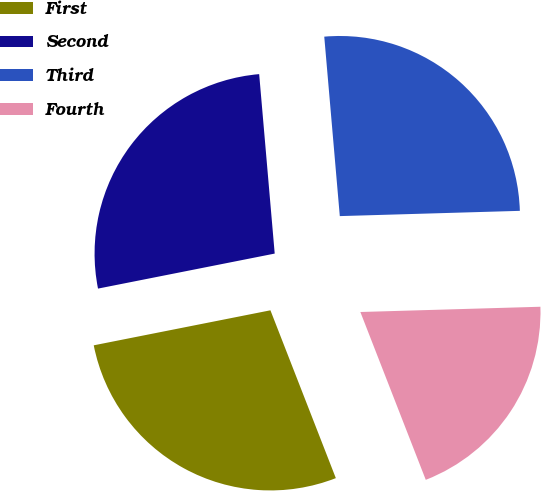<chart> <loc_0><loc_0><loc_500><loc_500><pie_chart><fcel>First<fcel>Second<fcel>Third<fcel>Fourth<nl><fcel>27.8%<fcel>26.74%<fcel>25.91%<fcel>19.55%<nl></chart> 